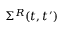Convert formula to latex. <formula><loc_0><loc_0><loc_500><loc_500>\Sigma ^ { R } ( t , t ^ { \prime } )</formula> 